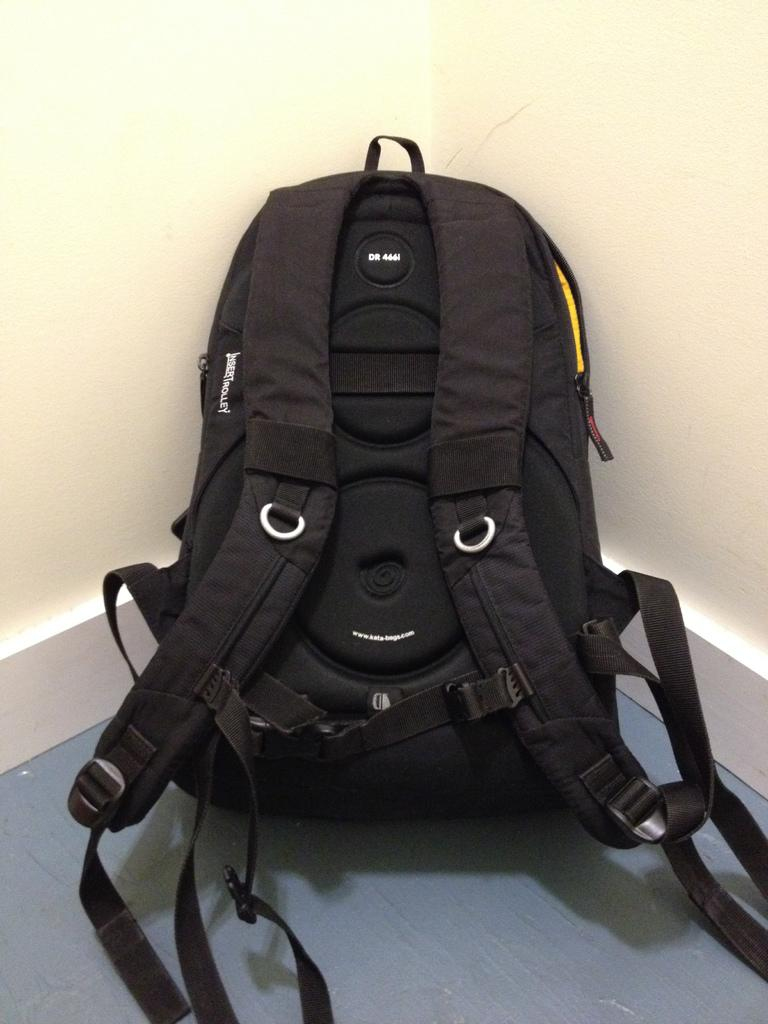What can be seen in the background of the image? There is a wall in the image. What type of object is present in the foreground of the image? There is a black color bag in the image. What type of pollution is visible in the image? There is no visible pollution in the image; it only features a wall and a black color bag. What reward is being offered for talking in the image? There is no reward or talking depicted in the image; it only features a wall and a black color bag. 